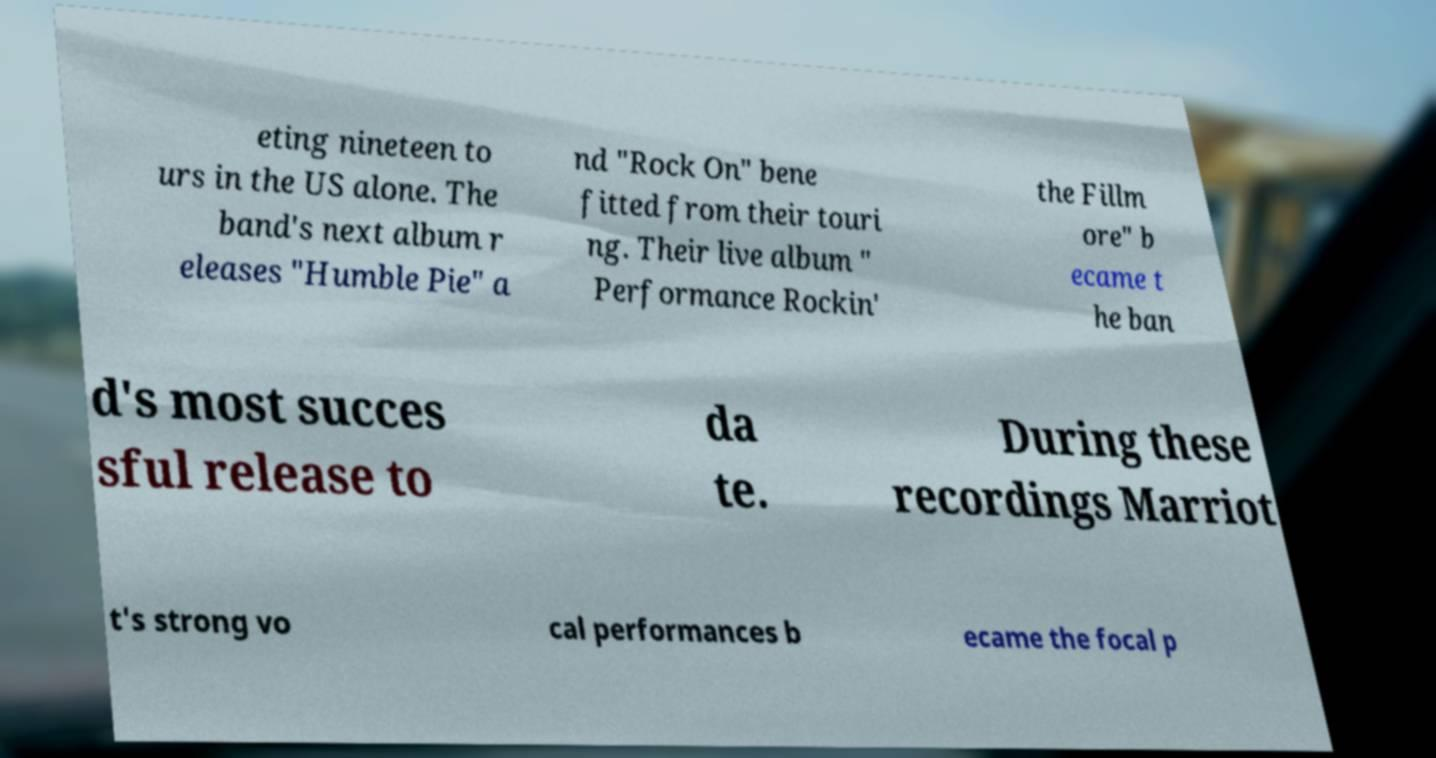Please identify and transcribe the text found in this image. eting nineteen to urs in the US alone. The band's next album r eleases "Humble Pie" a nd "Rock On" bene fitted from their touri ng. Their live album " Performance Rockin' the Fillm ore" b ecame t he ban d's most succes sful release to da te. During these recordings Marriot t's strong vo cal performances b ecame the focal p 